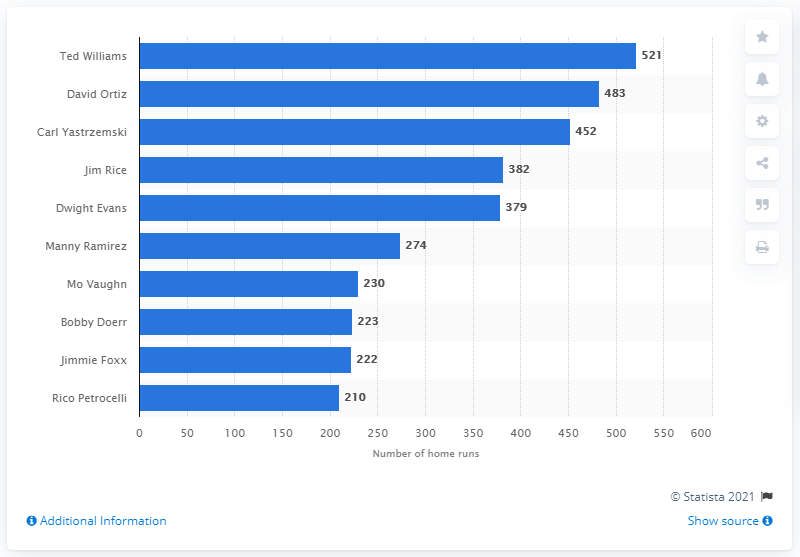Indicate a few pertinent items in this graphic. As of my knowledge cutoff date of September 2021, the total number of home runs hit by Ted Williams was 521. The Boston Red Sox franchise records indicate that Ted Williams holds the distinction of having hit the most home runs in the team's history. 